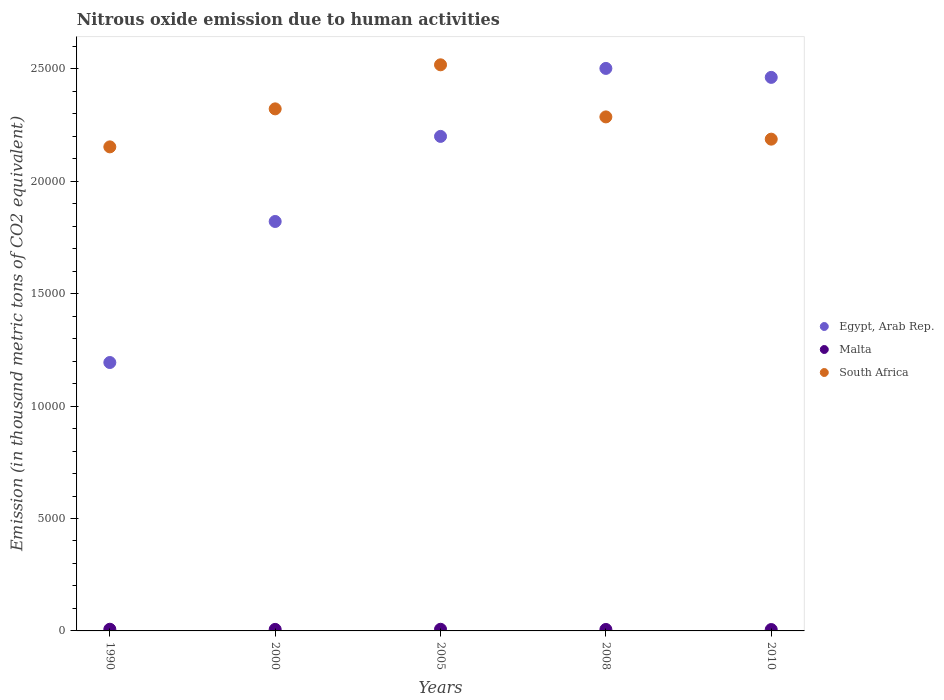How many different coloured dotlines are there?
Offer a terse response. 3. What is the amount of nitrous oxide emitted in Malta in 2010?
Make the answer very short. 60.9. Across all years, what is the maximum amount of nitrous oxide emitted in Malta?
Provide a succinct answer. 74.4. Across all years, what is the minimum amount of nitrous oxide emitted in Egypt, Arab Rep.?
Your answer should be very brief. 1.19e+04. In which year was the amount of nitrous oxide emitted in South Africa maximum?
Give a very brief answer. 2005. What is the total amount of nitrous oxide emitted in Malta in the graph?
Offer a very short reply. 341.4. What is the difference between the amount of nitrous oxide emitted in Egypt, Arab Rep. in 1990 and that in 2010?
Keep it short and to the point. -1.27e+04. What is the difference between the amount of nitrous oxide emitted in Egypt, Arab Rep. in 2005 and the amount of nitrous oxide emitted in Malta in 2010?
Your answer should be very brief. 2.19e+04. What is the average amount of nitrous oxide emitted in Egypt, Arab Rep. per year?
Your answer should be very brief. 2.04e+04. In the year 1990, what is the difference between the amount of nitrous oxide emitted in Egypt, Arab Rep. and amount of nitrous oxide emitted in South Africa?
Keep it short and to the point. -9590.2. What is the ratio of the amount of nitrous oxide emitted in Malta in 2008 to that in 2010?
Keep it short and to the point. 1.07. What is the difference between the highest and the second highest amount of nitrous oxide emitted in Egypt, Arab Rep.?
Provide a succinct answer. 398.3. What is the difference between the highest and the lowest amount of nitrous oxide emitted in South Africa?
Give a very brief answer. 3649.4. Is the sum of the amount of nitrous oxide emitted in Egypt, Arab Rep. in 2000 and 2008 greater than the maximum amount of nitrous oxide emitted in South Africa across all years?
Your answer should be very brief. Yes. Is it the case that in every year, the sum of the amount of nitrous oxide emitted in Malta and amount of nitrous oxide emitted in South Africa  is greater than the amount of nitrous oxide emitted in Egypt, Arab Rep.?
Offer a terse response. No. Does the amount of nitrous oxide emitted in Egypt, Arab Rep. monotonically increase over the years?
Provide a short and direct response. No. Is the amount of nitrous oxide emitted in South Africa strictly greater than the amount of nitrous oxide emitted in Egypt, Arab Rep. over the years?
Your answer should be very brief. No. How many dotlines are there?
Provide a short and direct response. 3. What is the difference between two consecutive major ticks on the Y-axis?
Ensure brevity in your answer.  5000. Does the graph contain grids?
Offer a terse response. No. Where does the legend appear in the graph?
Ensure brevity in your answer.  Center right. How many legend labels are there?
Your answer should be very brief. 3. What is the title of the graph?
Give a very brief answer. Nitrous oxide emission due to human activities. Does "Malaysia" appear as one of the legend labels in the graph?
Provide a succinct answer. No. What is the label or title of the Y-axis?
Keep it short and to the point. Emission (in thousand metric tons of CO2 equivalent). What is the Emission (in thousand metric tons of CO2 equivalent) of Egypt, Arab Rep. in 1990?
Give a very brief answer. 1.19e+04. What is the Emission (in thousand metric tons of CO2 equivalent) of Malta in 1990?
Your answer should be compact. 74.4. What is the Emission (in thousand metric tons of CO2 equivalent) of South Africa in 1990?
Your answer should be very brief. 2.15e+04. What is the Emission (in thousand metric tons of CO2 equivalent) of Egypt, Arab Rep. in 2000?
Ensure brevity in your answer.  1.82e+04. What is the Emission (in thousand metric tons of CO2 equivalent) of Malta in 2000?
Provide a succinct answer. 67.7. What is the Emission (in thousand metric tons of CO2 equivalent) of South Africa in 2000?
Your answer should be very brief. 2.32e+04. What is the Emission (in thousand metric tons of CO2 equivalent) of Egypt, Arab Rep. in 2005?
Make the answer very short. 2.20e+04. What is the Emission (in thousand metric tons of CO2 equivalent) of Malta in 2005?
Your response must be concise. 73.3. What is the Emission (in thousand metric tons of CO2 equivalent) of South Africa in 2005?
Offer a very short reply. 2.52e+04. What is the Emission (in thousand metric tons of CO2 equivalent) of Egypt, Arab Rep. in 2008?
Your answer should be compact. 2.50e+04. What is the Emission (in thousand metric tons of CO2 equivalent) in Malta in 2008?
Make the answer very short. 65.1. What is the Emission (in thousand metric tons of CO2 equivalent) of South Africa in 2008?
Your answer should be compact. 2.29e+04. What is the Emission (in thousand metric tons of CO2 equivalent) of Egypt, Arab Rep. in 2010?
Offer a terse response. 2.46e+04. What is the Emission (in thousand metric tons of CO2 equivalent) of Malta in 2010?
Ensure brevity in your answer.  60.9. What is the Emission (in thousand metric tons of CO2 equivalent) of South Africa in 2010?
Give a very brief answer. 2.19e+04. Across all years, what is the maximum Emission (in thousand metric tons of CO2 equivalent) in Egypt, Arab Rep.?
Your answer should be compact. 2.50e+04. Across all years, what is the maximum Emission (in thousand metric tons of CO2 equivalent) in Malta?
Keep it short and to the point. 74.4. Across all years, what is the maximum Emission (in thousand metric tons of CO2 equivalent) in South Africa?
Your response must be concise. 2.52e+04. Across all years, what is the minimum Emission (in thousand metric tons of CO2 equivalent) of Egypt, Arab Rep.?
Offer a very short reply. 1.19e+04. Across all years, what is the minimum Emission (in thousand metric tons of CO2 equivalent) of Malta?
Offer a very short reply. 60.9. Across all years, what is the minimum Emission (in thousand metric tons of CO2 equivalent) of South Africa?
Ensure brevity in your answer.  2.15e+04. What is the total Emission (in thousand metric tons of CO2 equivalent) in Egypt, Arab Rep. in the graph?
Offer a very short reply. 1.02e+05. What is the total Emission (in thousand metric tons of CO2 equivalent) in Malta in the graph?
Keep it short and to the point. 341.4. What is the total Emission (in thousand metric tons of CO2 equivalent) in South Africa in the graph?
Offer a terse response. 1.15e+05. What is the difference between the Emission (in thousand metric tons of CO2 equivalent) in Egypt, Arab Rep. in 1990 and that in 2000?
Your answer should be compact. -6272.2. What is the difference between the Emission (in thousand metric tons of CO2 equivalent) in Malta in 1990 and that in 2000?
Give a very brief answer. 6.7. What is the difference between the Emission (in thousand metric tons of CO2 equivalent) of South Africa in 1990 and that in 2000?
Offer a very short reply. -1690.3. What is the difference between the Emission (in thousand metric tons of CO2 equivalent) of Egypt, Arab Rep. in 1990 and that in 2005?
Offer a very short reply. -1.01e+04. What is the difference between the Emission (in thousand metric tons of CO2 equivalent) of South Africa in 1990 and that in 2005?
Your response must be concise. -3649.4. What is the difference between the Emission (in thousand metric tons of CO2 equivalent) of Egypt, Arab Rep. in 1990 and that in 2008?
Keep it short and to the point. -1.31e+04. What is the difference between the Emission (in thousand metric tons of CO2 equivalent) in Malta in 1990 and that in 2008?
Your response must be concise. 9.3. What is the difference between the Emission (in thousand metric tons of CO2 equivalent) of South Africa in 1990 and that in 2008?
Your answer should be compact. -1332.8. What is the difference between the Emission (in thousand metric tons of CO2 equivalent) of Egypt, Arab Rep. in 1990 and that in 2010?
Your answer should be very brief. -1.27e+04. What is the difference between the Emission (in thousand metric tons of CO2 equivalent) in Malta in 1990 and that in 2010?
Your answer should be very brief. 13.5. What is the difference between the Emission (in thousand metric tons of CO2 equivalent) of South Africa in 1990 and that in 2010?
Ensure brevity in your answer.  -343.1. What is the difference between the Emission (in thousand metric tons of CO2 equivalent) of Egypt, Arab Rep. in 2000 and that in 2005?
Your answer should be compact. -3783.9. What is the difference between the Emission (in thousand metric tons of CO2 equivalent) of Malta in 2000 and that in 2005?
Your answer should be compact. -5.6. What is the difference between the Emission (in thousand metric tons of CO2 equivalent) in South Africa in 2000 and that in 2005?
Keep it short and to the point. -1959.1. What is the difference between the Emission (in thousand metric tons of CO2 equivalent) in Egypt, Arab Rep. in 2000 and that in 2008?
Your answer should be compact. -6806.9. What is the difference between the Emission (in thousand metric tons of CO2 equivalent) of South Africa in 2000 and that in 2008?
Keep it short and to the point. 357.5. What is the difference between the Emission (in thousand metric tons of CO2 equivalent) in Egypt, Arab Rep. in 2000 and that in 2010?
Offer a very short reply. -6408.6. What is the difference between the Emission (in thousand metric tons of CO2 equivalent) in South Africa in 2000 and that in 2010?
Your answer should be very brief. 1347.2. What is the difference between the Emission (in thousand metric tons of CO2 equivalent) of Egypt, Arab Rep. in 2005 and that in 2008?
Offer a terse response. -3023. What is the difference between the Emission (in thousand metric tons of CO2 equivalent) in South Africa in 2005 and that in 2008?
Provide a short and direct response. 2316.6. What is the difference between the Emission (in thousand metric tons of CO2 equivalent) in Egypt, Arab Rep. in 2005 and that in 2010?
Your response must be concise. -2624.7. What is the difference between the Emission (in thousand metric tons of CO2 equivalent) in Malta in 2005 and that in 2010?
Give a very brief answer. 12.4. What is the difference between the Emission (in thousand metric tons of CO2 equivalent) in South Africa in 2005 and that in 2010?
Keep it short and to the point. 3306.3. What is the difference between the Emission (in thousand metric tons of CO2 equivalent) in Egypt, Arab Rep. in 2008 and that in 2010?
Ensure brevity in your answer.  398.3. What is the difference between the Emission (in thousand metric tons of CO2 equivalent) in Malta in 2008 and that in 2010?
Ensure brevity in your answer.  4.2. What is the difference between the Emission (in thousand metric tons of CO2 equivalent) in South Africa in 2008 and that in 2010?
Provide a short and direct response. 989.7. What is the difference between the Emission (in thousand metric tons of CO2 equivalent) in Egypt, Arab Rep. in 1990 and the Emission (in thousand metric tons of CO2 equivalent) in Malta in 2000?
Keep it short and to the point. 1.19e+04. What is the difference between the Emission (in thousand metric tons of CO2 equivalent) of Egypt, Arab Rep. in 1990 and the Emission (in thousand metric tons of CO2 equivalent) of South Africa in 2000?
Offer a terse response. -1.13e+04. What is the difference between the Emission (in thousand metric tons of CO2 equivalent) in Malta in 1990 and the Emission (in thousand metric tons of CO2 equivalent) in South Africa in 2000?
Your answer should be compact. -2.31e+04. What is the difference between the Emission (in thousand metric tons of CO2 equivalent) in Egypt, Arab Rep. in 1990 and the Emission (in thousand metric tons of CO2 equivalent) in Malta in 2005?
Give a very brief answer. 1.19e+04. What is the difference between the Emission (in thousand metric tons of CO2 equivalent) of Egypt, Arab Rep. in 1990 and the Emission (in thousand metric tons of CO2 equivalent) of South Africa in 2005?
Give a very brief answer. -1.32e+04. What is the difference between the Emission (in thousand metric tons of CO2 equivalent) of Malta in 1990 and the Emission (in thousand metric tons of CO2 equivalent) of South Africa in 2005?
Provide a short and direct response. -2.51e+04. What is the difference between the Emission (in thousand metric tons of CO2 equivalent) in Egypt, Arab Rep. in 1990 and the Emission (in thousand metric tons of CO2 equivalent) in Malta in 2008?
Provide a short and direct response. 1.19e+04. What is the difference between the Emission (in thousand metric tons of CO2 equivalent) in Egypt, Arab Rep. in 1990 and the Emission (in thousand metric tons of CO2 equivalent) in South Africa in 2008?
Your answer should be compact. -1.09e+04. What is the difference between the Emission (in thousand metric tons of CO2 equivalent) in Malta in 1990 and the Emission (in thousand metric tons of CO2 equivalent) in South Africa in 2008?
Provide a succinct answer. -2.28e+04. What is the difference between the Emission (in thousand metric tons of CO2 equivalent) in Egypt, Arab Rep. in 1990 and the Emission (in thousand metric tons of CO2 equivalent) in Malta in 2010?
Provide a succinct answer. 1.19e+04. What is the difference between the Emission (in thousand metric tons of CO2 equivalent) of Egypt, Arab Rep. in 1990 and the Emission (in thousand metric tons of CO2 equivalent) of South Africa in 2010?
Your response must be concise. -9933.3. What is the difference between the Emission (in thousand metric tons of CO2 equivalent) of Malta in 1990 and the Emission (in thousand metric tons of CO2 equivalent) of South Africa in 2010?
Ensure brevity in your answer.  -2.18e+04. What is the difference between the Emission (in thousand metric tons of CO2 equivalent) of Egypt, Arab Rep. in 2000 and the Emission (in thousand metric tons of CO2 equivalent) of Malta in 2005?
Your response must be concise. 1.81e+04. What is the difference between the Emission (in thousand metric tons of CO2 equivalent) in Egypt, Arab Rep. in 2000 and the Emission (in thousand metric tons of CO2 equivalent) in South Africa in 2005?
Your response must be concise. -6967.4. What is the difference between the Emission (in thousand metric tons of CO2 equivalent) in Malta in 2000 and the Emission (in thousand metric tons of CO2 equivalent) in South Africa in 2005?
Keep it short and to the point. -2.51e+04. What is the difference between the Emission (in thousand metric tons of CO2 equivalent) in Egypt, Arab Rep. in 2000 and the Emission (in thousand metric tons of CO2 equivalent) in Malta in 2008?
Your answer should be compact. 1.81e+04. What is the difference between the Emission (in thousand metric tons of CO2 equivalent) of Egypt, Arab Rep. in 2000 and the Emission (in thousand metric tons of CO2 equivalent) of South Africa in 2008?
Offer a very short reply. -4650.8. What is the difference between the Emission (in thousand metric tons of CO2 equivalent) in Malta in 2000 and the Emission (in thousand metric tons of CO2 equivalent) in South Africa in 2008?
Your answer should be compact. -2.28e+04. What is the difference between the Emission (in thousand metric tons of CO2 equivalent) of Egypt, Arab Rep. in 2000 and the Emission (in thousand metric tons of CO2 equivalent) of Malta in 2010?
Ensure brevity in your answer.  1.81e+04. What is the difference between the Emission (in thousand metric tons of CO2 equivalent) in Egypt, Arab Rep. in 2000 and the Emission (in thousand metric tons of CO2 equivalent) in South Africa in 2010?
Your answer should be compact. -3661.1. What is the difference between the Emission (in thousand metric tons of CO2 equivalent) of Malta in 2000 and the Emission (in thousand metric tons of CO2 equivalent) of South Africa in 2010?
Ensure brevity in your answer.  -2.18e+04. What is the difference between the Emission (in thousand metric tons of CO2 equivalent) of Egypt, Arab Rep. in 2005 and the Emission (in thousand metric tons of CO2 equivalent) of Malta in 2008?
Provide a short and direct response. 2.19e+04. What is the difference between the Emission (in thousand metric tons of CO2 equivalent) of Egypt, Arab Rep. in 2005 and the Emission (in thousand metric tons of CO2 equivalent) of South Africa in 2008?
Ensure brevity in your answer.  -866.9. What is the difference between the Emission (in thousand metric tons of CO2 equivalent) of Malta in 2005 and the Emission (in thousand metric tons of CO2 equivalent) of South Africa in 2008?
Provide a succinct answer. -2.28e+04. What is the difference between the Emission (in thousand metric tons of CO2 equivalent) of Egypt, Arab Rep. in 2005 and the Emission (in thousand metric tons of CO2 equivalent) of Malta in 2010?
Offer a very short reply. 2.19e+04. What is the difference between the Emission (in thousand metric tons of CO2 equivalent) of Egypt, Arab Rep. in 2005 and the Emission (in thousand metric tons of CO2 equivalent) of South Africa in 2010?
Keep it short and to the point. 122.8. What is the difference between the Emission (in thousand metric tons of CO2 equivalent) in Malta in 2005 and the Emission (in thousand metric tons of CO2 equivalent) in South Africa in 2010?
Provide a succinct answer. -2.18e+04. What is the difference between the Emission (in thousand metric tons of CO2 equivalent) of Egypt, Arab Rep. in 2008 and the Emission (in thousand metric tons of CO2 equivalent) of Malta in 2010?
Your answer should be very brief. 2.50e+04. What is the difference between the Emission (in thousand metric tons of CO2 equivalent) of Egypt, Arab Rep. in 2008 and the Emission (in thousand metric tons of CO2 equivalent) of South Africa in 2010?
Ensure brevity in your answer.  3145.8. What is the difference between the Emission (in thousand metric tons of CO2 equivalent) of Malta in 2008 and the Emission (in thousand metric tons of CO2 equivalent) of South Africa in 2010?
Make the answer very short. -2.18e+04. What is the average Emission (in thousand metric tons of CO2 equivalent) in Egypt, Arab Rep. per year?
Ensure brevity in your answer.  2.04e+04. What is the average Emission (in thousand metric tons of CO2 equivalent) of Malta per year?
Offer a terse response. 68.28. What is the average Emission (in thousand metric tons of CO2 equivalent) of South Africa per year?
Your answer should be compact. 2.29e+04. In the year 1990, what is the difference between the Emission (in thousand metric tons of CO2 equivalent) in Egypt, Arab Rep. and Emission (in thousand metric tons of CO2 equivalent) in Malta?
Make the answer very short. 1.19e+04. In the year 1990, what is the difference between the Emission (in thousand metric tons of CO2 equivalent) in Egypt, Arab Rep. and Emission (in thousand metric tons of CO2 equivalent) in South Africa?
Your answer should be very brief. -9590.2. In the year 1990, what is the difference between the Emission (in thousand metric tons of CO2 equivalent) in Malta and Emission (in thousand metric tons of CO2 equivalent) in South Africa?
Provide a succinct answer. -2.15e+04. In the year 2000, what is the difference between the Emission (in thousand metric tons of CO2 equivalent) in Egypt, Arab Rep. and Emission (in thousand metric tons of CO2 equivalent) in Malta?
Provide a succinct answer. 1.81e+04. In the year 2000, what is the difference between the Emission (in thousand metric tons of CO2 equivalent) in Egypt, Arab Rep. and Emission (in thousand metric tons of CO2 equivalent) in South Africa?
Provide a short and direct response. -5008.3. In the year 2000, what is the difference between the Emission (in thousand metric tons of CO2 equivalent) of Malta and Emission (in thousand metric tons of CO2 equivalent) of South Africa?
Your answer should be very brief. -2.31e+04. In the year 2005, what is the difference between the Emission (in thousand metric tons of CO2 equivalent) in Egypt, Arab Rep. and Emission (in thousand metric tons of CO2 equivalent) in Malta?
Provide a short and direct response. 2.19e+04. In the year 2005, what is the difference between the Emission (in thousand metric tons of CO2 equivalent) of Egypt, Arab Rep. and Emission (in thousand metric tons of CO2 equivalent) of South Africa?
Give a very brief answer. -3183.5. In the year 2005, what is the difference between the Emission (in thousand metric tons of CO2 equivalent) in Malta and Emission (in thousand metric tons of CO2 equivalent) in South Africa?
Offer a very short reply. -2.51e+04. In the year 2008, what is the difference between the Emission (in thousand metric tons of CO2 equivalent) in Egypt, Arab Rep. and Emission (in thousand metric tons of CO2 equivalent) in Malta?
Your response must be concise. 2.50e+04. In the year 2008, what is the difference between the Emission (in thousand metric tons of CO2 equivalent) in Egypt, Arab Rep. and Emission (in thousand metric tons of CO2 equivalent) in South Africa?
Your answer should be compact. 2156.1. In the year 2008, what is the difference between the Emission (in thousand metric tons of CO2 equivalent) in Malta and Emission (in thousand metric tons of CO2 equivalent) in South Africa?
Your answer should be compact. -2.28e+04. In the year 2010, what is the difference between the Emission (in thousand metric tons of CO2 equivalent) in Egypt, Arab Rep. and Emission (in thousand metric tons of CO2 equivalent) in Malta?
Offer a very short reply. 2.46e+04. In the year 2010, what is the difference between the Emission (in thousand metric tons of CO2 equivalent) in Egypt, Arab Rep. and Emission (in thousand metric tons of CO2 equivalent) in South Africa?
Your answer should be compact. 2747.5. In the year 2010, what is the difference between the Emission (in thousand metric tons of CO2 equivalent) of Malta and Emission (in thousand metric tons of CO2 equivalent) of South Africa?
Provide a succinct answer. -2.18e+04. What is the ratio of the Emission (in thousand metric tons of CO2 equivalent) in Egypt, Arab Rep. in 1990 to that in 2000?
Offer a terse response. 0.66. What is the ratio of the Emission (in thousand metric tons of CO2 equivalent) in Malta in 1990 to that in 2000?
Ensure brevity in your answer.  1.1. What is the ratio of the Emission (in thousand metric tons of CO2 equivalent) in South Africa in 1990 to that in 2000?
Give a very brief answer. 0.93. What is the ratio of the Emission (in thousand metric tons of CO2 equivalent) in Egypt, Arab Rep. in 1990 to that in 2005?
Your response must be concise. 0.54. What is the ratio of the Emission (in thousand metric tons of CO2 equivalent) of South Africa in 1990 to that in 2005?
Ensure brevity in your answer.  0.85. What is the ratio of the Emission (in thousand metric tons of CO2 equivalent) of Egypt, Arab Rep. in 1990 to that in 2008?
Offer a very short reply. 0.48. What is the ratio of the Emission (in thousand metric tons of CO2 equivalent) in Malta in 1990 to that in 2008?
Your answer should be compact. 1.14. What is the ratio of the Emission (in thousand metric tons of CO2 equivalent) of South Africa in 1990 to that in 2008?
Your response must be concise. 0.94. What is the ratio of the Emission (in thousand metric tons of CO2 equivalent) of Egypt, Arab Rep. in 1990 to that in 2010?
Make the answer very short. 0.48. What is the ratio of the Emission (in thousand metric tons of CO2 equivalent) of Malta in 1990 to that in 2010?
Your response must be concise. 1.22. What is the ratio of the Emission (in thousand metric tons of CO2 equivalent) in South Africa in 1990 to that in 2010?
Give a very brief answer. 0.98. What is the ratio of the Emission (in thousand metric tons of CO2 equivalent) in Egypt, Arab Rep. in 2000 to that in 2005?
Keep it short and to the point. 0.83. What is the ratio of the Emission (in thousand metric tons of CO2 equivalent) in Malta in 2000 to that in 2005?
Provide a short and direct response. 0.92. What is the ratio of the Emission (in thousand metric tons of CO2 equivalent) in South Africa in 2000 to that in 2005?
Offer a very short reply. 0.92. What is the ratio of the Emission (in thousand metric tons of CO2 equivalent) in Egypt, Arab Rep. in 2000 to that in 2008?
Keep it short and to the point. 0.73. What is the ratio of the Emission (in thousand metric tons of CO2 equivalent) of Malta in 2000 to that in 2008?
Keep it short and to the point. 1.04. What is the ratio of the Emission (in thousand metric tons of CO2 equivalent) in South Africa in 2000 to that in 2008?
Ensure brevity in your answer.  1.02. What is the ratio of the Emission (in thousand metric tons of CO2 equivalent) in Egypt, Arab Rep. in 2000 to that in 2010?
Your response must be concise. 0.74. What is the ratio of the Emission (in thousand metric tons of CO2 equivalent) in Malta in 2000 to that in 2010?
Keep it short and to the point. 1.11. What is the ratio of the Emission (in thousand metric tons of CO2 equivalent) of South Africa in 2000 to that in 2010?
Give a very brief answer. 1.06. What is the ratio of the Emission (in thousand metric tons of CO2 equivalent) in Egypt, Arab Rep. in 2005 to that in 2008?
Make the answer very short. 0.88. What is the ratio of the Emission (in thousand metric tons of CO2 equivalent) of Malta in 2005 to that in 2008?
Offer a very short reply. 1.13. What is the ratio of the Emission (in thousand metric tons of CO2 equivalent) in South Africa in 2005 to that in 2008?
Your answer should be compact. 1.1. What is the ratio of the Emission (in thousand metric tons of CO2 equivalent) in Egypt, Arab Rep. in 2005 to that in 2010?
Your answer should be very brief. 0.89. What is the ratio of the Emission (in thousand metric tons of CO2 equivalent) of Malta in 2005 to that in 2010?
Your answer should be very brief. 1.2. What is the ratio of the Emission (in thousand metric tons of CO2 equivalent) in South Africa in 2005 to that in 2010?
Provide a succinct answer. 1.15. What is the ratio of the Emission (in thousand metric tons of CO2 equivalent) of Egypt, Arab Rep. in 2008 to that in 2010?
Your answer should be very brief. 1.02. What is the ratio of the Emission (in thousand metric tons of CO2 equivalent) in Malta in 2008 to that in 2010?
Provide a succinct answer. 1.07. What is the ratio of the Emission (in thousand metric tons of CO2 equivalent) of South Africa in 2008 to that in 2010?
Offer a terse response. 1.05. What is the difference between the highest and the second highest Emission (in thousand metric tons of CO2 equivalent) in Egypt, Arab Rep.?
Your answer should be compact. 398.3. What is the difference between the highest and the second highest Emission (in thousand metric tons of CO2 equivalent) in South Africa?
Your response must be concise. 1959.1. What is the difference between the highest and the lowest Emission (in thousand metric tons of CO2 equivalent) of Egypt, Arab Rep.?
Provide a succinct answer. 1.31e+04. What is the difference between the highest and the lowest Emission (in thousand metric tons of CO2 equivalent) of South Africa?
Your answer should be very brief. 3649.4. 